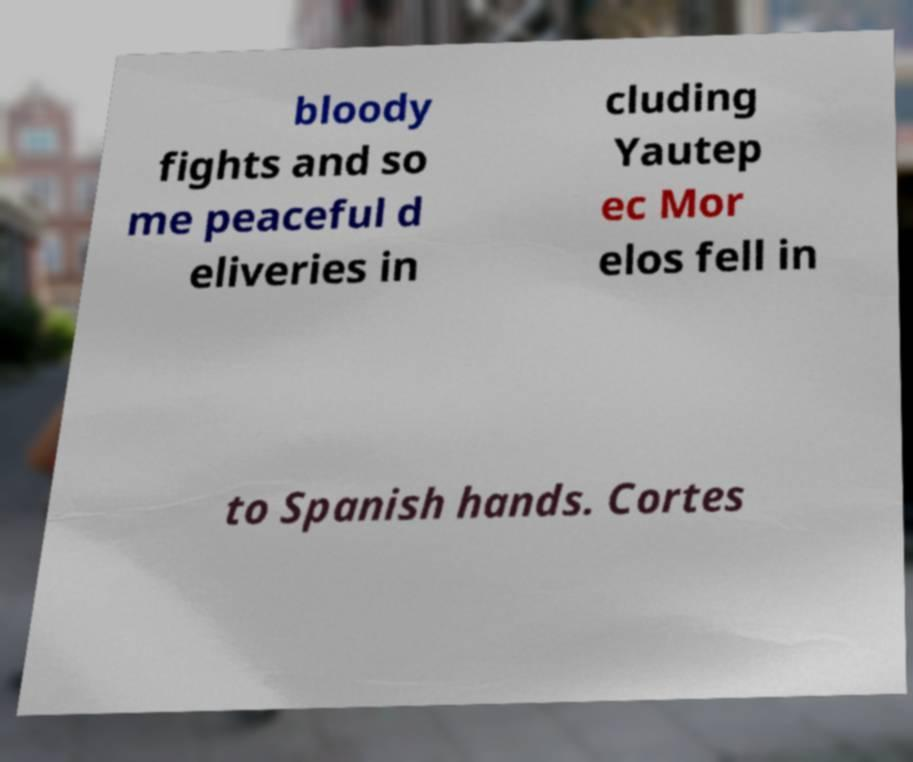Please read and relay the text visible in this image. What does it say? bloody fights and so me peaceful d eliveries in cluding Yautep ec Mor elos fell in to Spanish hands. Cortes 